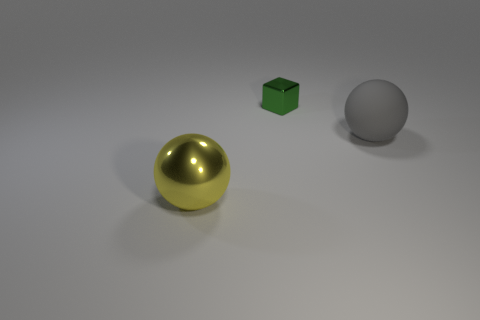Is the material of the large yellow object the same as the gray sphere?
Your answer should be compact. No. How many things are big spheres to the right of the tiny green metal thing or spheres right of the tiny metallic thing?
Offer a very short reply. 1. The other thing that is the same shape as the large gray thing is what color?
Your response must be concise. Yellow. How many metal things are the same color as the big matte thing?
Make the answer very short. 0. How many objects are large things that are right of the metal sphere or large shiny objects?
Provide a succinct answer. 2. There is a object right of the shiny object right of the large sphere on the left side of the green shiny object; what color is it?
Your answer should be compact. Gray. What is the color of the large ball that is made of the same material as the tiny cube?
Make the answer very short. Yellow. How many small red spheres have the same material as the small green object?
Give a very brief answer. 0. There is a sphere left of the gray matte ball; is its size the same as the matte ball?
Your response must be concise. Yes. What color is the ball that is the same size as the gray object?
Give a very brief answer. Yellow. 